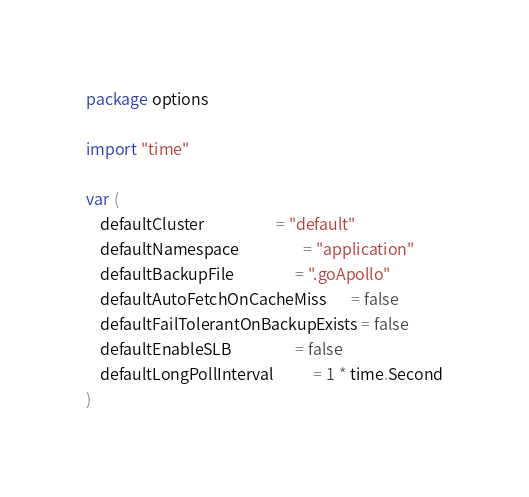Convert code to text. <code><loc_0><loc_0><loc_500><loc_500><_Go_>package options

import "time"

var (
	defaultCluster                    = "default"
	defaultNamespace                  = "application"
	defaultBackupFile                 = ".goApollo"
	defaultAutoFetchOnCacheMiss       = false
	defaultFailTolerantOnBackupExists = false
	defaultEnableSLB                  = false
	defaultLongPollInterval           = 1 * time.Second
)
</code> 